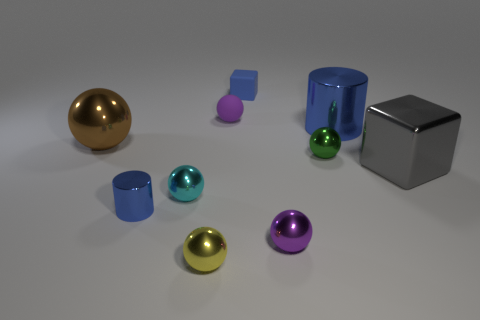Subtract all small rubber spheres. How many spheres are left? 5 Subtract all purple cubes. How many purple balls are left? 2 Subtract all yellow balls. How many balls are left? 5 Subtract 4 spheres. How many spheres are left? 2 Subtract all blocks. How many objects are left? 8 Add 1 large metallic blocks. How many large metallic blocks exist? 2 Subtract 1 green spheres. How many objects are left? 9 Subtract all gray balls. Subtract all blue cylinders. How many balls are left? 6 Subtract all big cubes. Subtract all green shiny cylinders. How many objects are left? 9 Add 9 purple matte spheres. How many purple matte spheres are left? 10 